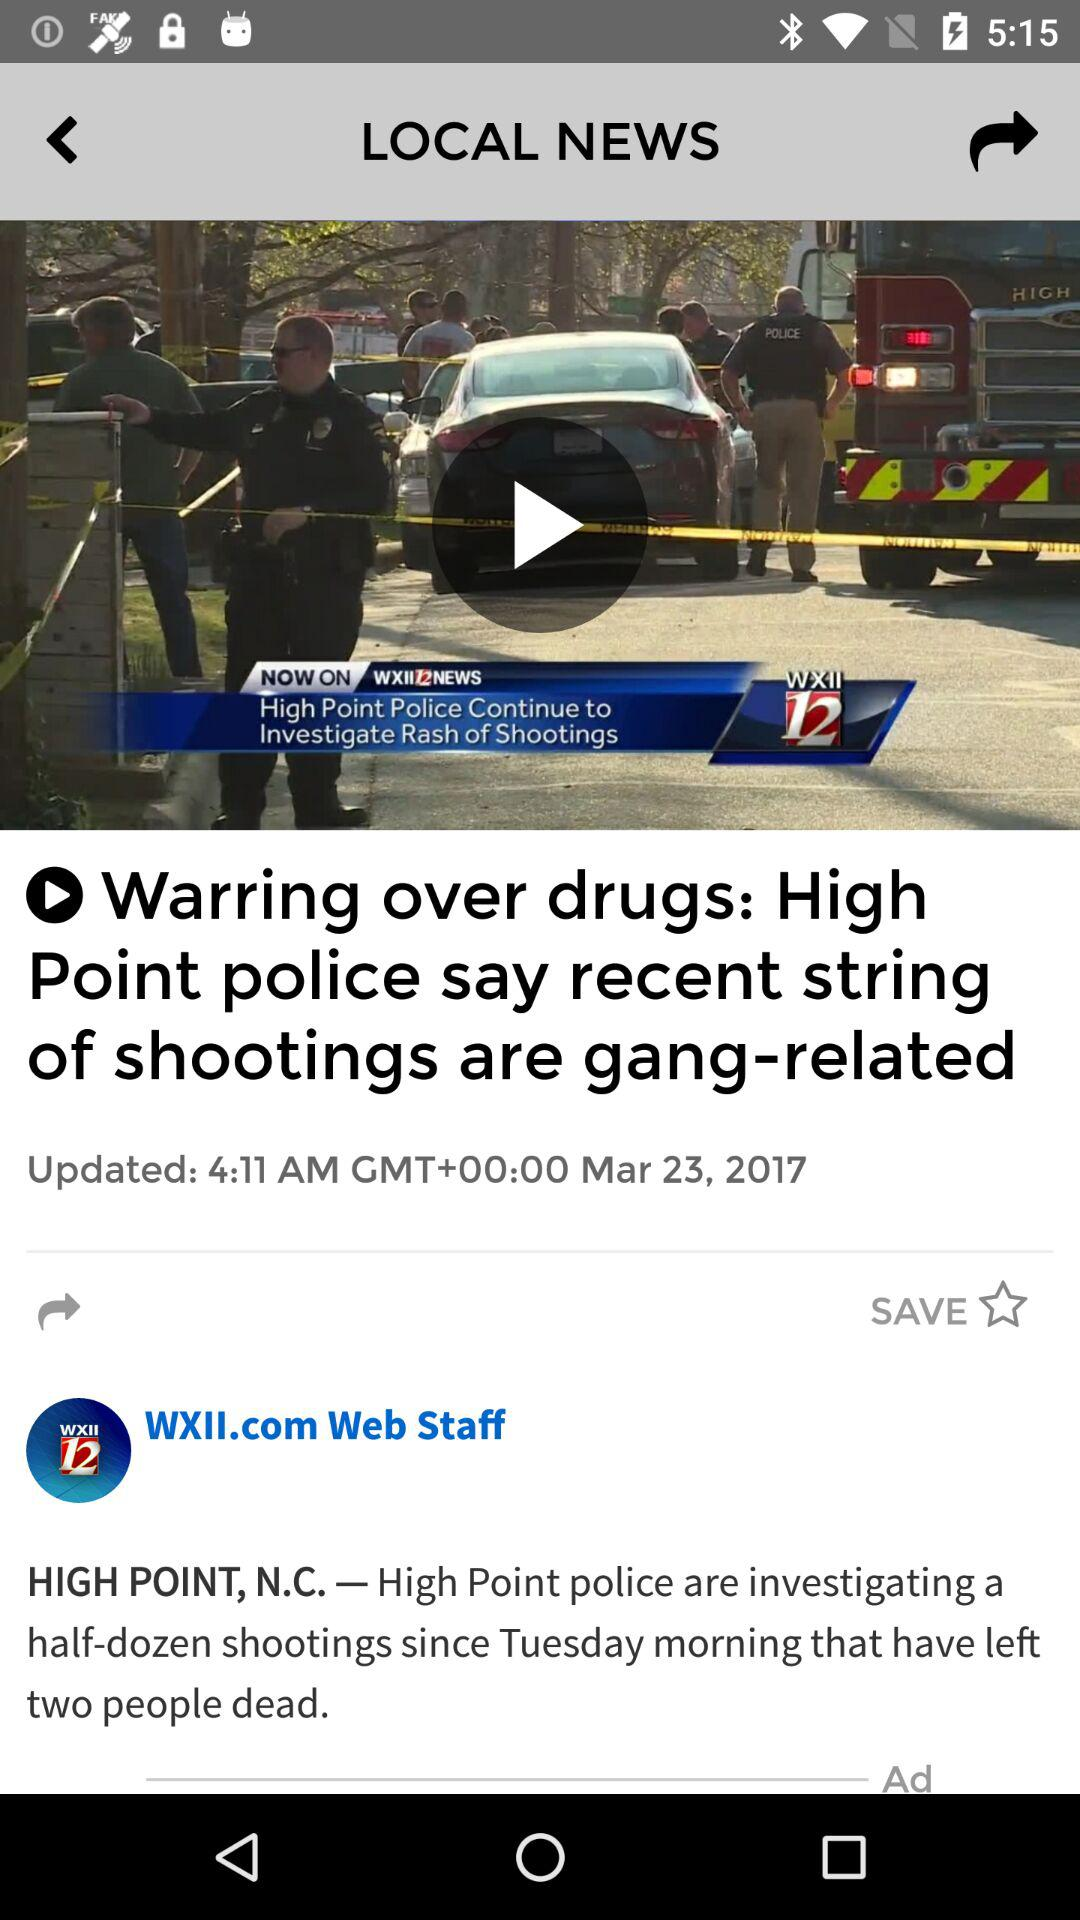What is the name of the article's author? The name is "WXII.com Web Staff". 